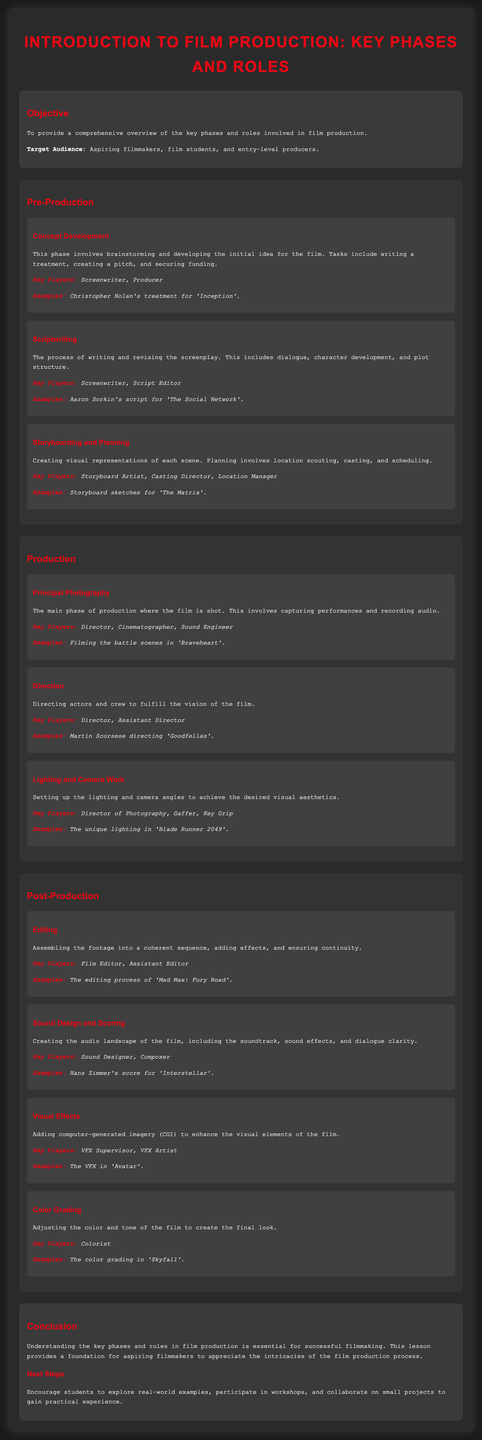What is the objective of the lesson? The objective is to provide a comprehensive overview of the key phases and roles involved in film production.
Answer: Comprehensive overview of key phases and roles Who is the target audience for the lesson? The target audience includes aspiring filmmakers, film students, and entry-level producers.
Answer: Aspiring filmmakers, film students, and entry-level producers Name a key player involved in concept development. A key player in this phase is the screenwriter.
Answer: Screenwriter In which phase is principal photography conducted? Principal photography is part of the production phase.
Answer: Production What role is responsible for editing in post-production? The film editor is responsible for editing in post-production.
Answer: Film Editor Which example is given for lighting and camera work? The unique lighting in 'Blade Runner 2049' is provided as an example.
Answer: The unique lighting in 'Blade Runner 2049' What is the final step mentioned in the conclusion? The final step encourages students to participate in workshops.
Answer: Participation in workshops How many types of post-production processes are listed? Four types of post-production processes are listed.
Answer: Four What is the main activity during the production phase? The main activity is shooting the film.
Answer: Shooting the film 